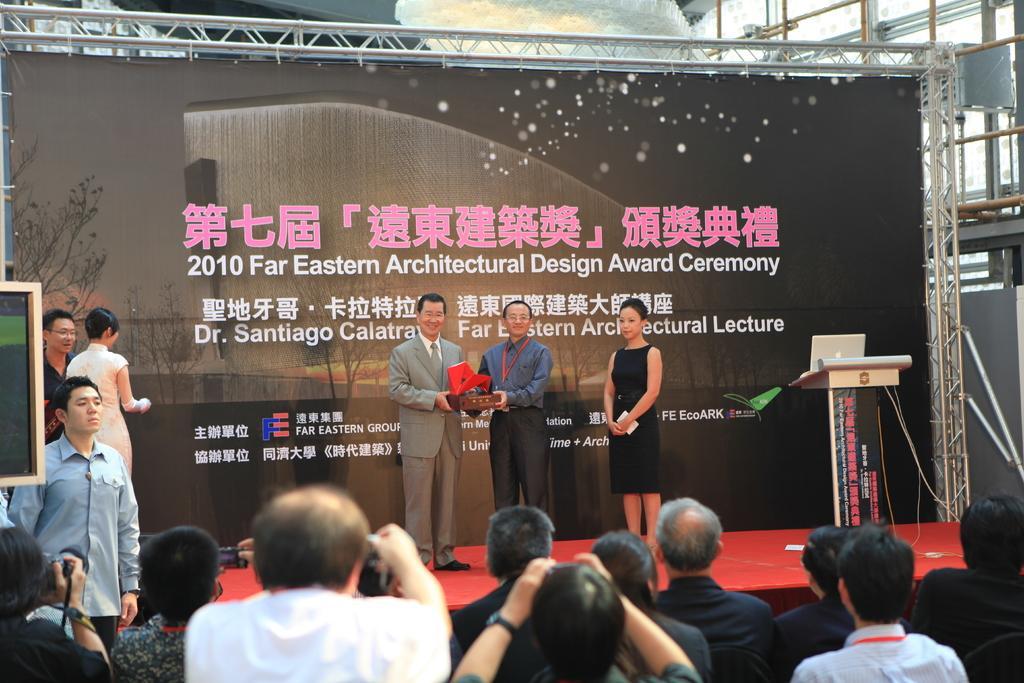Describe this image in one or two sentences. In this image I can see number of people in the front and in the background. I can also see a black colour board in the background and on it I can see something is written. On the right side of this image I can see a podium and on it I can see a laptop. I can also see a board on the left side of this image. 